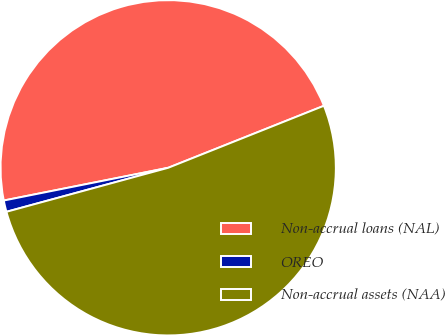Convert chart to OTSL. <chart><loc_0><loc_0><loc_500><loc_500><pie_chart><fcel>Non-accrual loans (NAL)<fcel>OREO<fcel>Non-accrual assets (NAA)<nl><fcel>47.1%<fcel>1.1%<fcel>51.81%<nl></chart> 